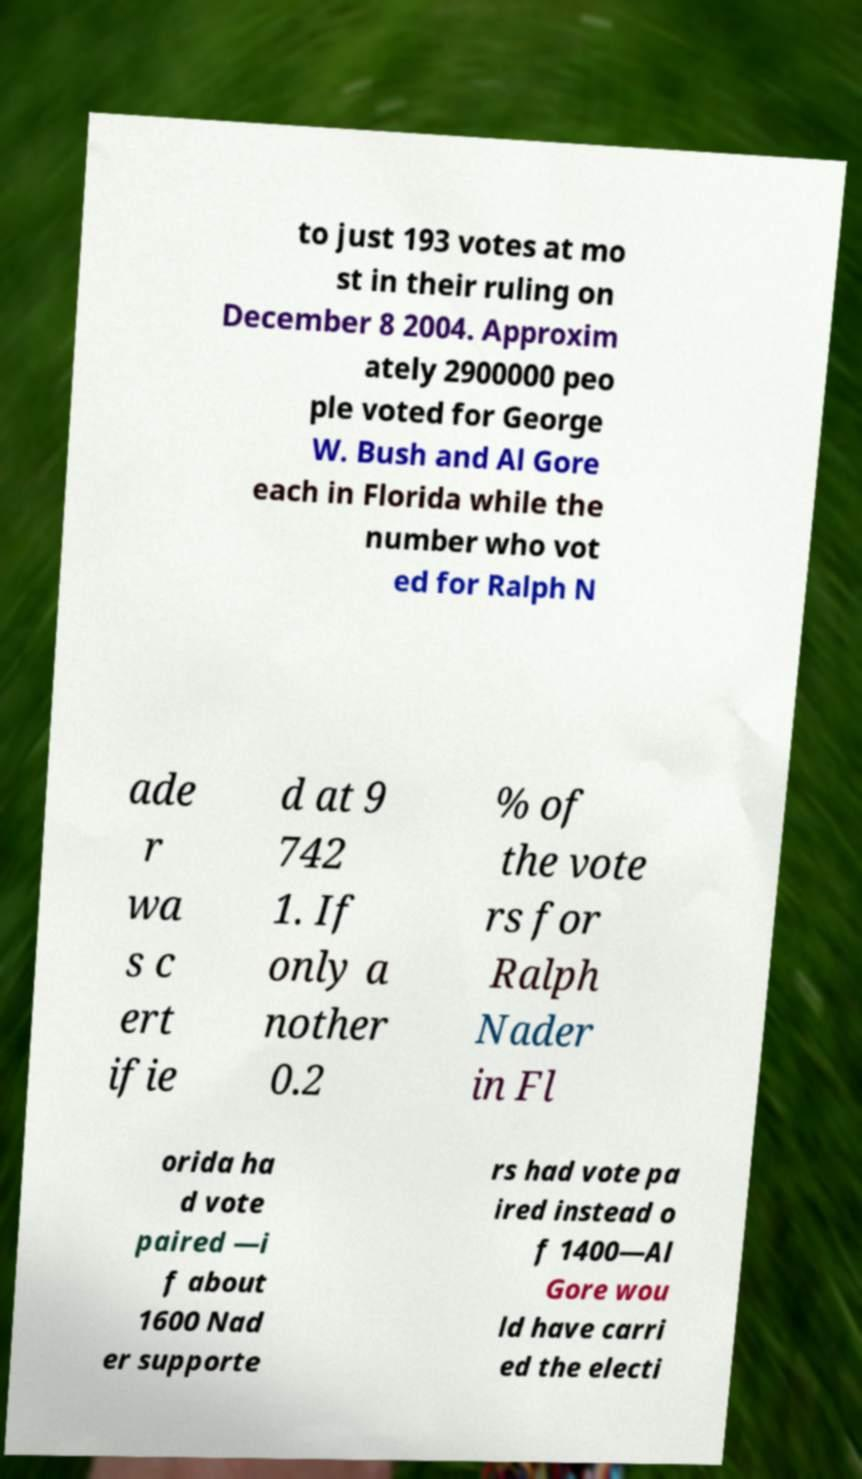Please identify and transcribe the text found in this image. to just 193 votes at mo st in their ruling on December 8 2004. Approxim ately 2900000 peo ple voted for George W. Bush and Al Gore each in Florida while the number who vot ed for Ralph N ade r wa s c ert ifie d at 9 742 1. If only a nother 0.2 % of the vote rs for Ralph Nader in Fl orida ha d vote paired —i f about 1600 Nad er supporte rs had vote pa ired instead o f 1400—Al Gore wou ld have carri ed the electi 